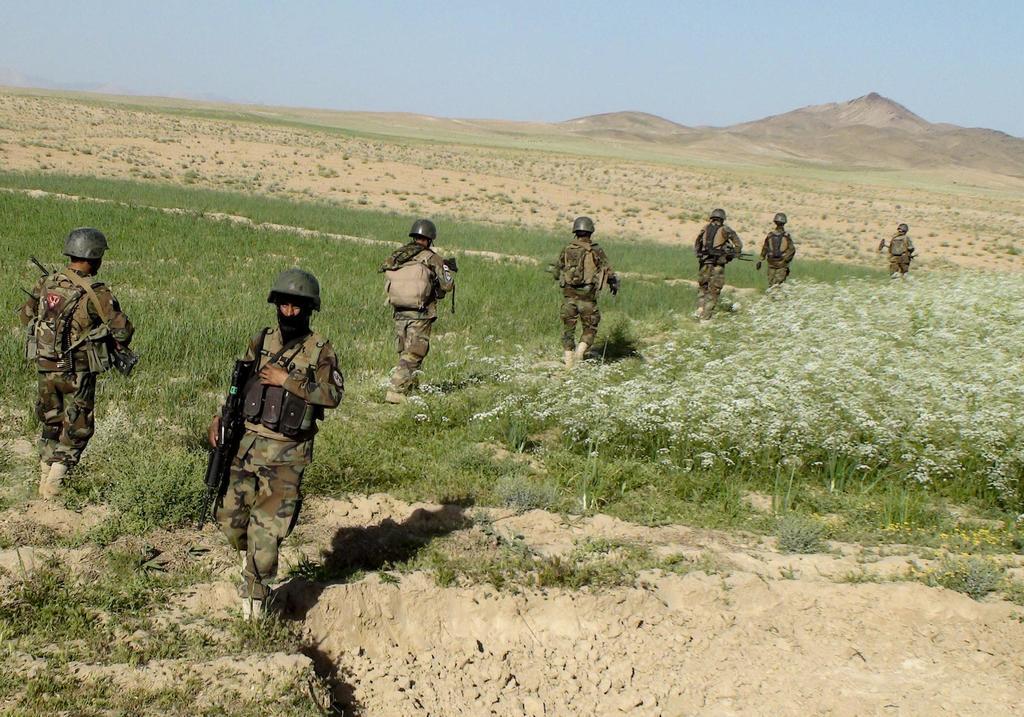Can you describe this image briefly? In the foreground of this image, there are few persons in military dress holding guns in their hands are walking on the grass. In the background, there are plants, grass, mountains and the sky. 